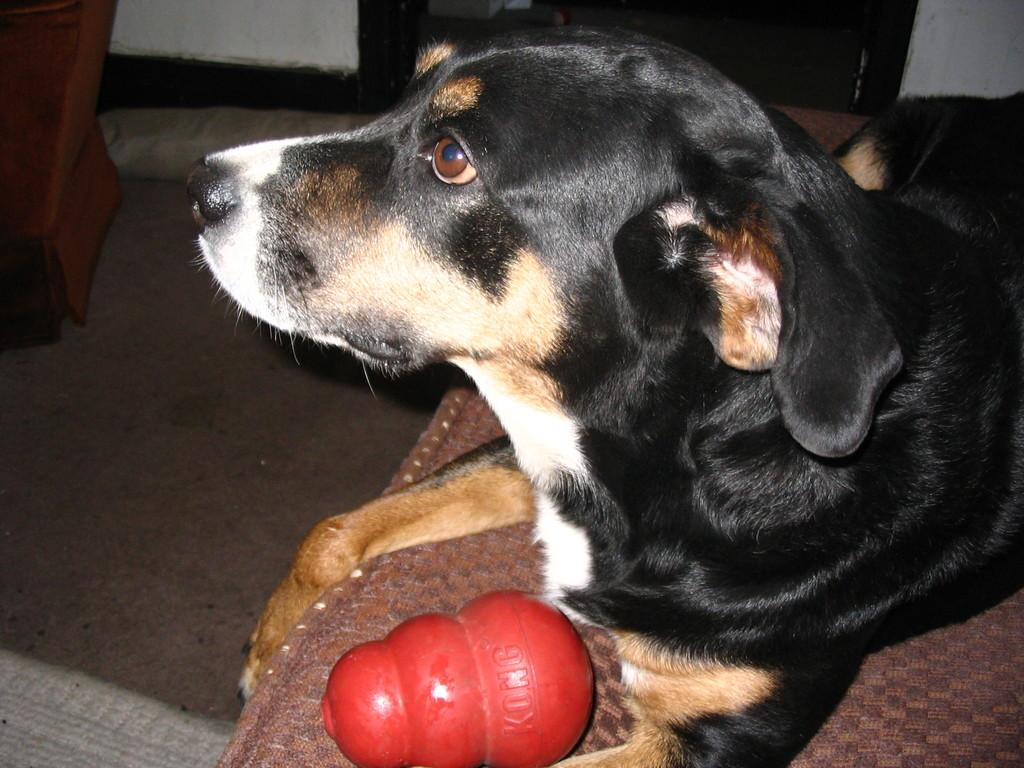What type of animal is on the bed in the image? There is a dog on the bed in the image. Can you describe the object in the image? Unfortunately, the facts provided do not give any information about the object in the image. What can be seen in the background of the image? There is a stand and a wall visible in the background of the image. What is the surface that the bed is resting on? There is a floor visible at the bottom of the image. What type of suit is the dog wearing around its throat in the image? There is no suit or any clothing on the dog in the image. 